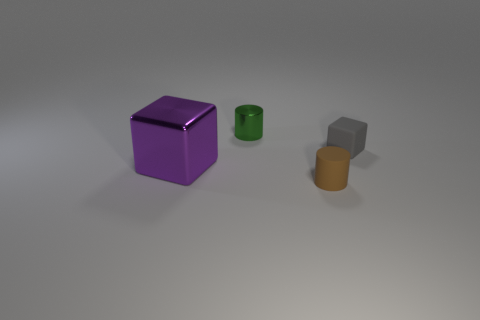Are there any gray blocks that have the same material as the small brown object?
Keep it short and to the point. Yes. Is the material of the brown cylinder the same as the gray object?
Offer a terse response. Yes. What number of metal blocks are behind the cube that is to the left of the green metallic cylinder?
Your response must be concise. 0. How many gray objects are small matte things or small cylinders?
Offer a terse response. 1. What shape is the small gray rubber object that is behind the metallic object in front of the small metal object that is to the left of the gray rubber object?
Your answer should be compact. Cube. What is the color of the cube that is the same size as the brown cylinder?
Your response must be concise. Gray. How many other objects have the same shape as the gray thing?
Provide a succinct answer. 1. There is a purple thing; is its size the same as the cylinder that is behind the big purple metallic object?
Your answer should be compact. No. What shape is the small thing that is behind the small rubber thing that is on the right side of the tiny matte cylinder?
Your answer should be compact. Cylinder. Is the number of purple things behind the purple metallic thing less than the number of blue rubber spheres?
Ensure brevity in your answer.  No. 